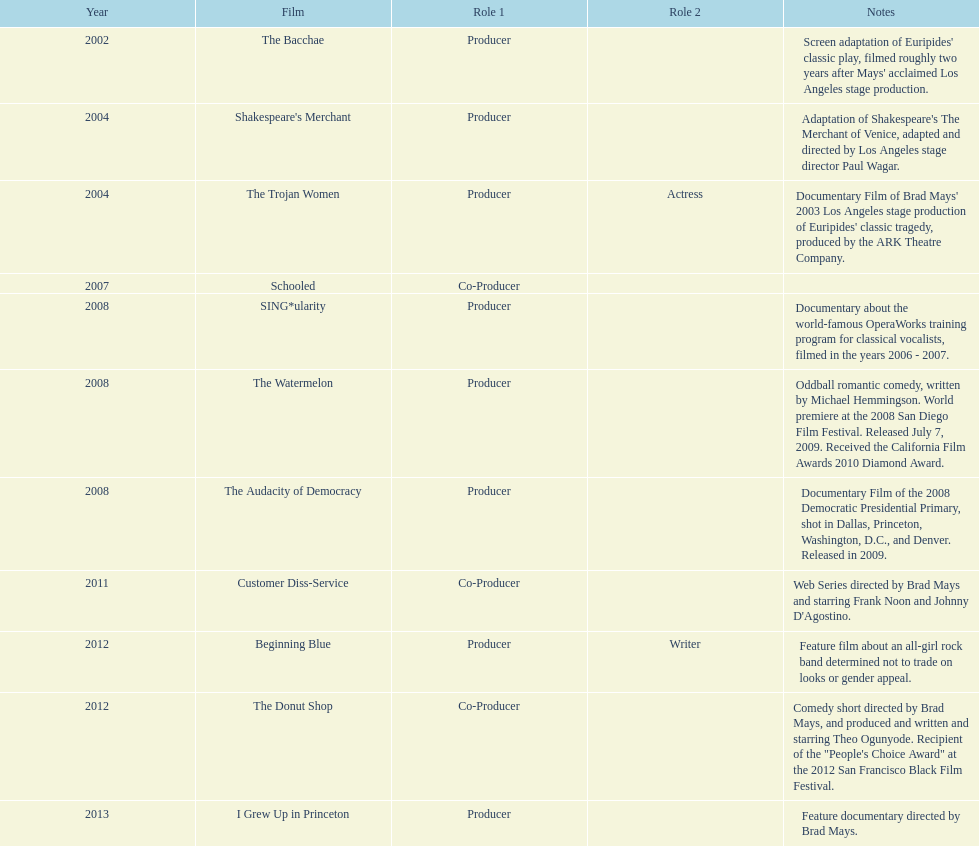How many years before was the film bacchae out before the watermelon? 6. 